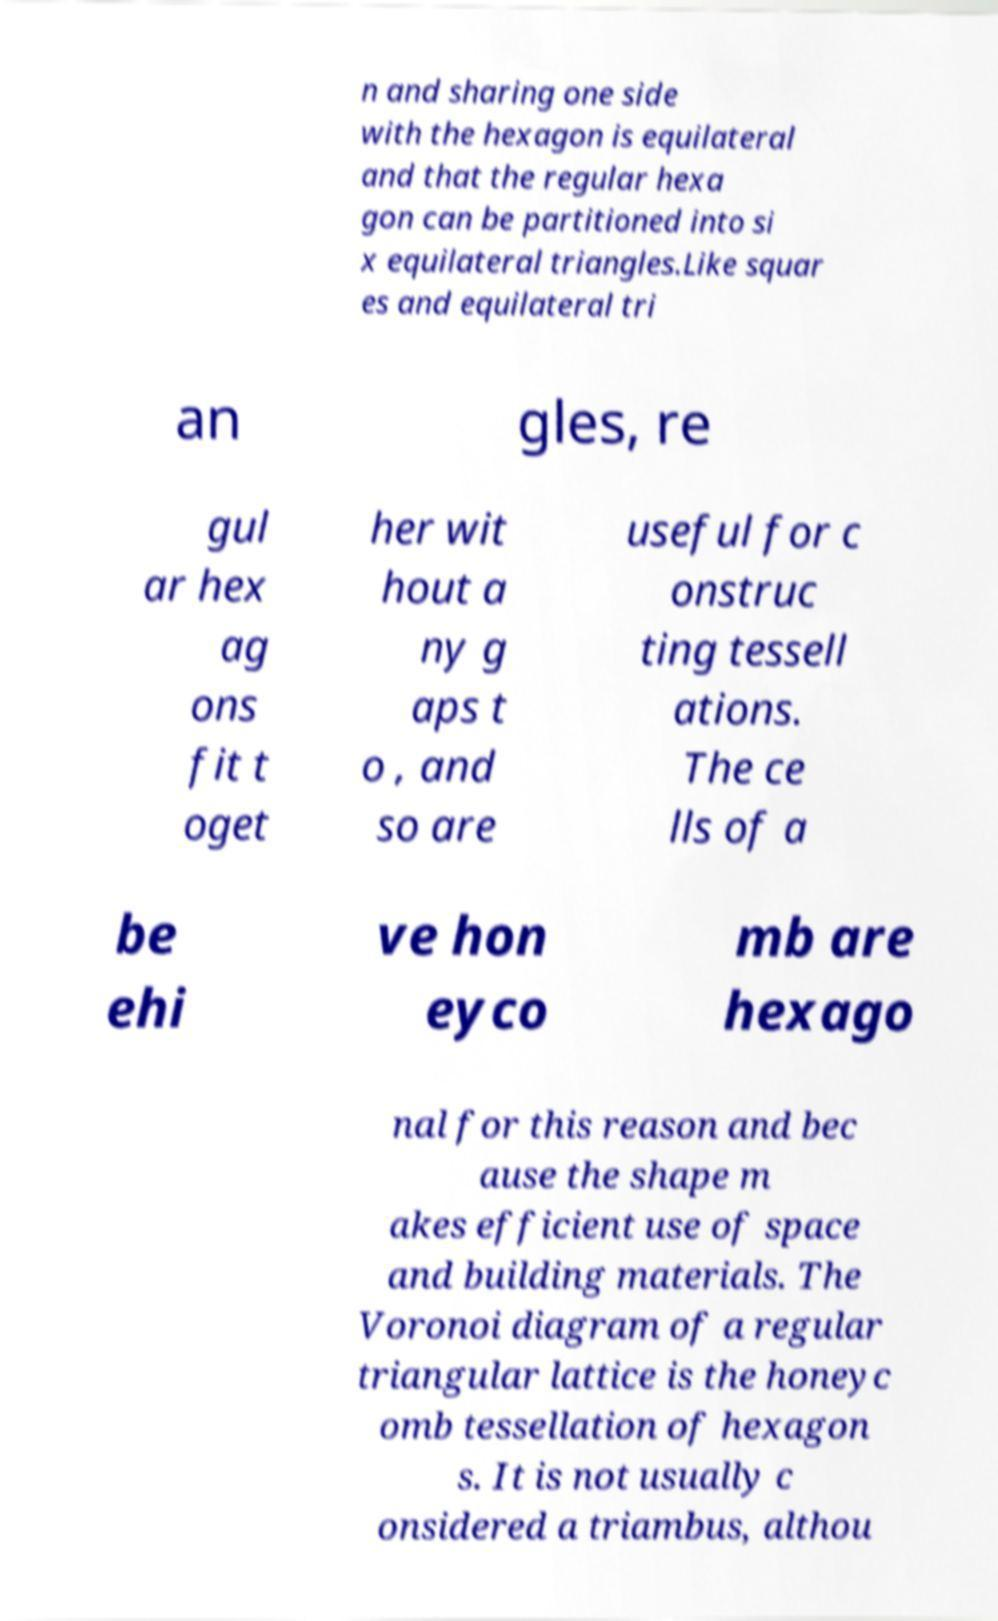Could you assist in decoding the text presented in this image and type it out clearly? n and sharing one side with the hexagon is equilateral and that the regular hexa gon can be partitioned into si x equilateral triangles.Like squar es and equilateral tri an gles, re gul ar hex ag ons fit t oget her wit hout a ny g aps t o , and so are useful for c onstruc ting tessell ations. The ce lls of a be ehi ve hon eyco mb are hexago nal for this reason and bec ause the shape m akes efficient use of space and building materials. The Voronoi diagram of a regular triangular lattice is the honeyc omb tessellation of hexagon s. It is not usually c onsidered a triambus, althou 